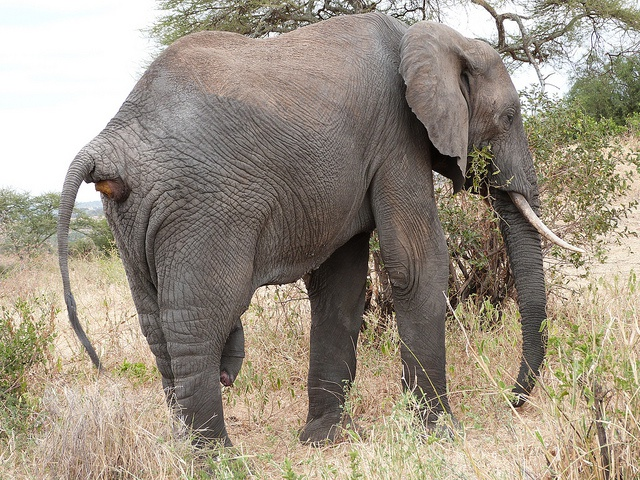Describe the objects in this image and their specific colors. I can see a elephant in white, gray, darkgray, and black tones in this image. 